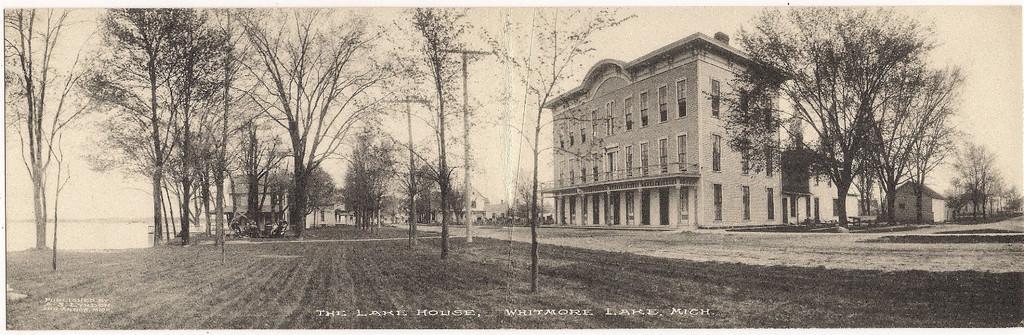Describe this image in one or two sentences. In this picture I can see in the middle there are trees, on the right side there are buildings. At the bottom there is the text, this image is in black and white color. 